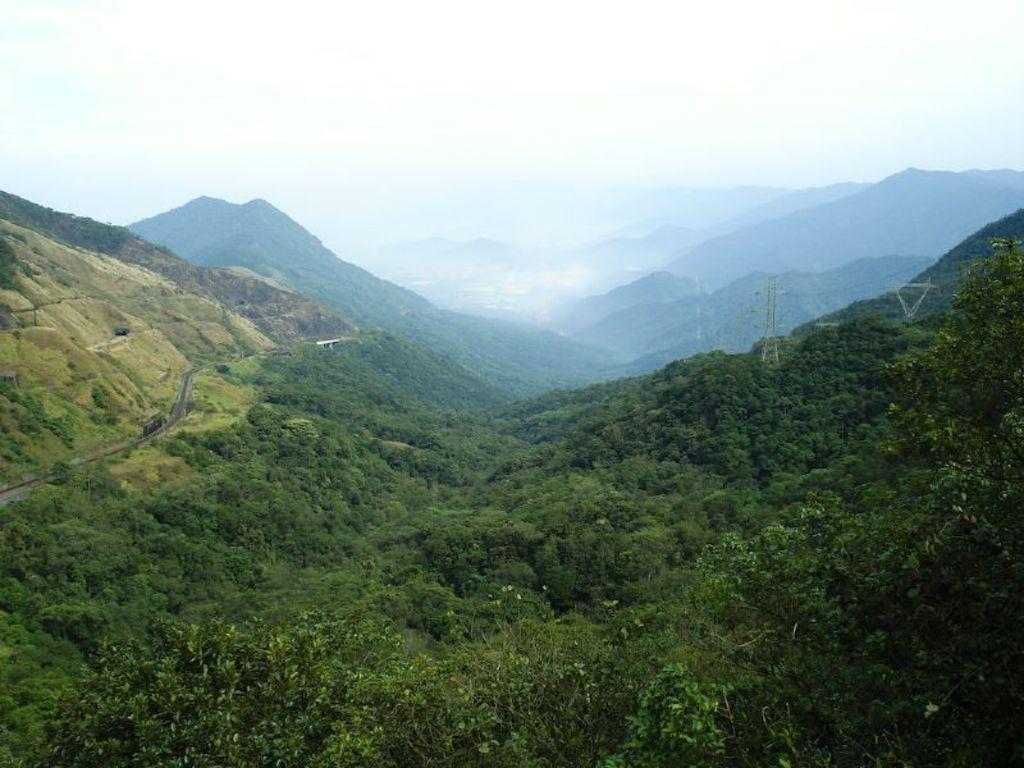In one or two sentences, can you explain what this image depicts? In this image I can see trees in green color, background I can see mountains and the sky is in white color. 